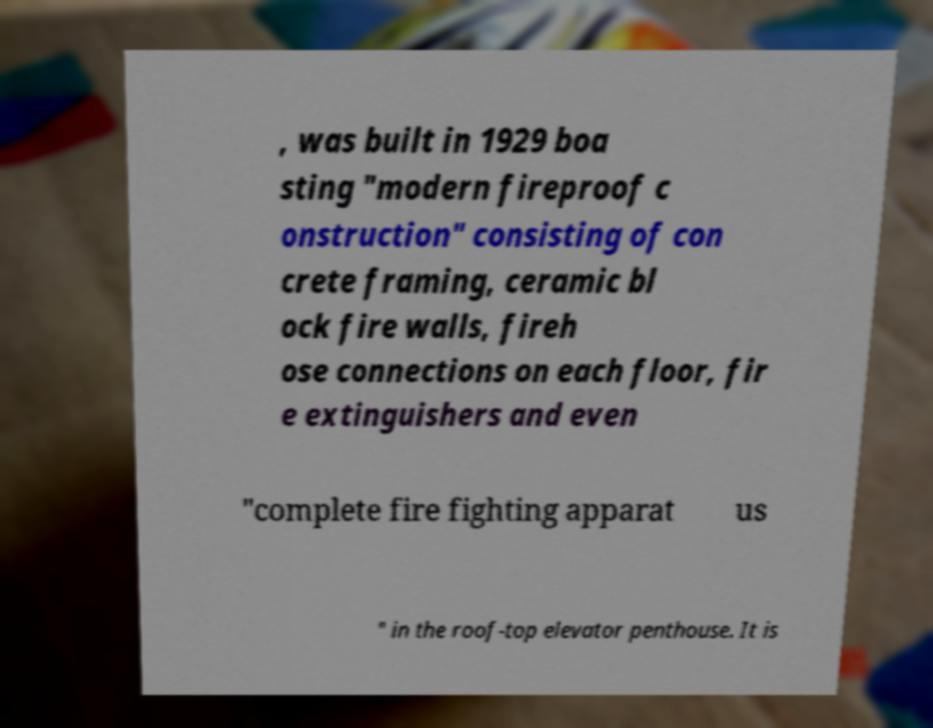Please identify and transcribe the text found in this image. , was built in 1929 boa sting "modern fireproof c onstruction" consisting of con crete framing, ceramic bl ock fire walls, fireh ose connections on each floor, fir e extinguishers and even "complete fire fighting apparat us " in the roof-top elevator penthouse. It is 